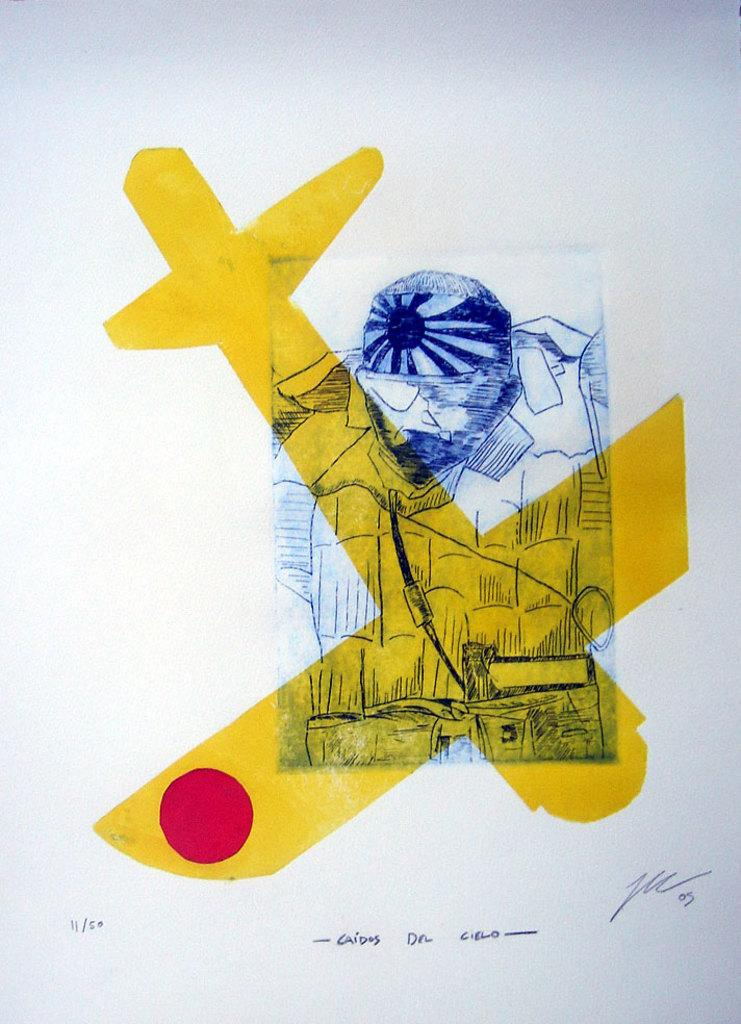What is depicted on the paper in the image? The image contains a paper with a drawing on it. Can you describe the drawing on the paper? The drawing appears to be of a person. Is there any indication of authorship on the paper? Yes, there is a signature on the paper. What type of band can be seen performing in the image? There is no band present in the image; it only contains a paper with a drawing of a person and a signature. 